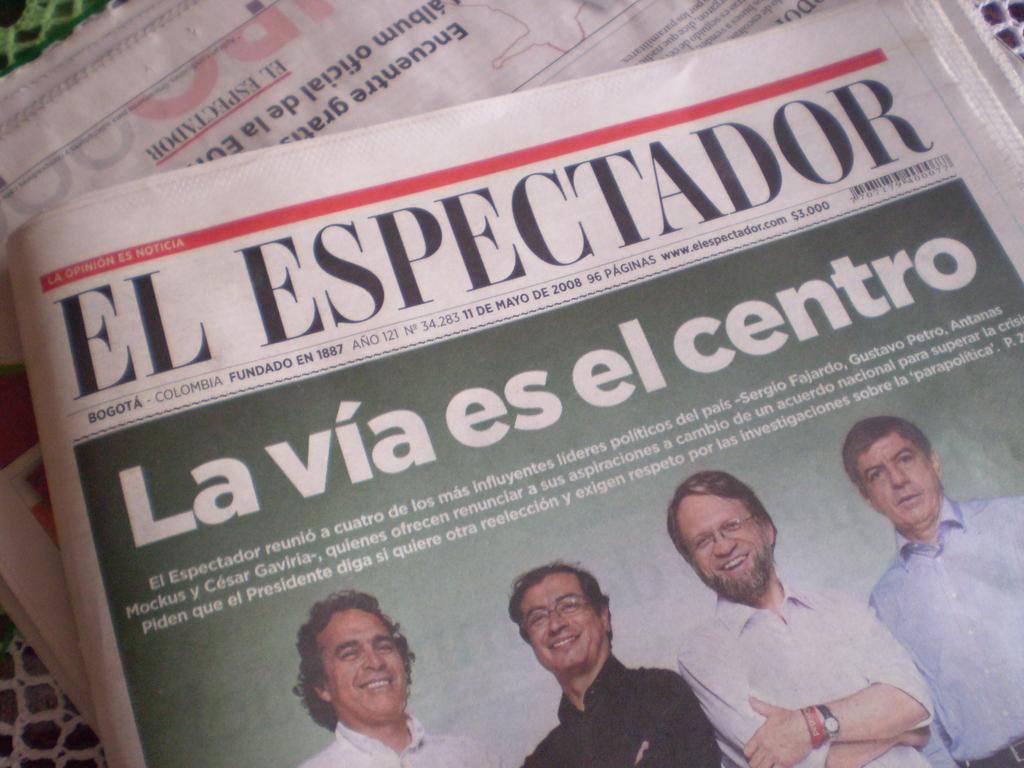In one or two sentences, can you explain what this image depicts? In this picture we can see newspapers on a platform, where we can see some people and some text on it. 